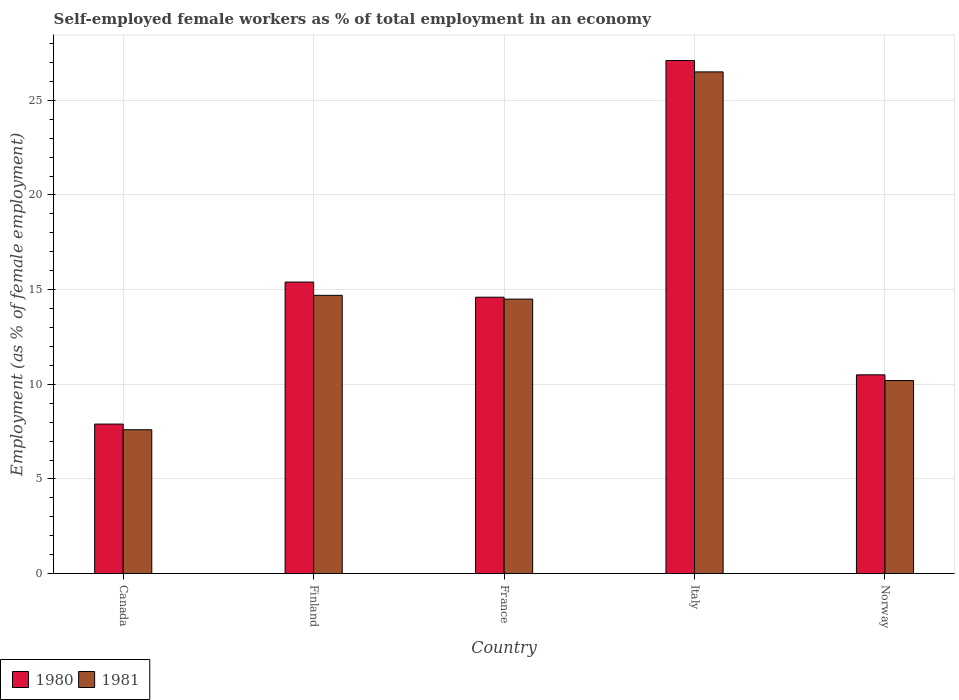Are the number of bars per tick equal to the number of legend labels?
Your answer should be compact. Yes. What is the label of the 5th group of bars from the left?
Your answer should be very brief. Norway. In how many cases, is the number of bars for a given country not equal to the number of legend labels?
Your answer should be compact. 0. What is the percentage of self-employed female workers in 1981 in France?
Your answer should be very brief. 14.5. Across all countries, what is the maximum percentage of self-employed female workers in 1980?
Give a very brief answer. 27.1. Across all countries, what is the minimum percentage of self-employed female workers in 1981?
Keep it short and to the point. 7.6. In which country was the percentage of self-employed female workers in 1981 minimum?
Keep it short and to the point. Canada. What is the total percentage of self-employed female workers in 1980 in the graph?
Offer a very short reply. 75.5. What is the difference between the percentage of self-employed female workers in 1980 in Canada and that in Italy?
Provide a short and direct response. -19.2. What is the difference between the percentage of self-employed female workers in 1981 in France and the percentage of self-employed female workers in 1980 in Italy?
Your answer should be compact. -12.6. What is the average percentage of self-employed female workers in 1980 per country?
Keep it short and to the point. 15.1. What is the difference between the percentage of self-employed female workers of/in 1981 and percentage of self-employed female workers of/in 1980 in Norway?
Offer a very short reply. -0.3. What is the ratio of the percentage of self-employed female workers in 1980 in Finland to that in France?
Your answer should be very brief. 1.05. What is the difference between the highest and the second highest percentage of self-employed female workers in 1981?
Keep it short and to the point. 11.8. What is the difference between the highest and the lowest percentage of self-employed female workers in 1981?
Make the answer very short. 18.9. In how many countries, is the percentage of self-employed female workers in 1980 greater than the average percentage of self-employed female workers in 1980 taken over all countries?
Provide a succinct answer. 2. What does the 2nd bar from the left in France represents?
Offer a very short reply. 1981. How many bars are there?
Your response must be concise. 10. How many countries are there in the graph?
Your answer should be very brief. 5. What is the difference between two consecutive major ticks on the Y-axis?
Provide a succinct answer. 5. Does the graph contain any zero values?
Your answer should be compact. No. Does the graph contain grids?
Make the answer very short. Yes. Where does the legend appear in the graph?
Ensure brevity in your answer.  Bottom left. How many legend labels are there?
Make the answer very short. 2. What is the title of the graph?
Your response must be concise. Self-employed female workers as % of total employment in an economy. What is the label or title of the X-axis?
Provide a succinct answer. Country. What is the label or title of the Y-axis?
Provide a succinct answer. Employment (as % of female employment). What is the Employment (as % of female employment) in 1980 in Canada?
Make the answer very short. 7.9. What is the Employment (as % of female employment) in 1981 in Canada?
Ensure brevity in your answer.  7.6. What is the Employment (as % of female employment) of 1980 in Finland?
Your answer should be compact. 15.4. What is the Employment (as % of female employment) of 1981 in Finland?
Give a very brief answer. 14.7. What is the Employment (as % of female employment) in 1980 in France?
Your answer should be very brief. 14.6. What is the Employment (as % of female employment) of 1980 in Italy?
Your answer should be compact. 27.1. What is the Employment (as % of female employment) of 1981 in Italy?
Provide a short and direct response. 26.5. What is the Employment (as % of female employment) of 1980 in Norway?
Your answer should be compact. 10.5. What is the Employment (as % of female employment) of 1981 in Norway?
Ensure brevity in your answer.  10.2. Across all countries, what is the maximum Employment (as % of female employment) in 1980?
Keep it short and to the point. 27.1. Across all countries, what is the minimum Employment (as % of female employment) of 1980?
Your response must be concise. 7.9. Across all countries, what is the minimum Employment (as % of female employment) of 1981?
Provide a succinct answer. 7.6. What is the total Employment (as % of female employment) in 1980 in the graph?
Your response must be concise. 75.5. What is the total Employment (as % of female employment) in 1981 in the graph?
Offer a terse response. 73.5. What is the difference between the Employment (as % of female employment) of 1980 in Canada and that in Italy?
Provide a short and direct response. -19.2. What is the difference between the Employment (as % of female employment) of 1981 in Canada and that in Italy?
Provide a succinct answer. -18.9. What is the difference between the Employment (as % of female employment) of 1980 in Canada and that in Norway?
Make the answer very short. -2.6. What is the difference between the Employment (as % of female employment) in 1980 in Finland and that in France?
Offer a very short reply. 0.8. What is the difference between the Employment (as % of female employment) of 1981 in Finland and that in France?
Offer a terse response. 0.2. What is the difference between the Employment (as % of female employment) of 1981 in Finland and that in Italy?
Keep it short and to the point. -11.8. What is the difference between the Employment (as % of female employment) in 1980 in Finland and that in Norway?
Offer a very short reply. 4.9. What is the difference between the Employment (as % of female employment) in 1981 in France and that in Italy?
Give a very brief answer. -12. What is the difference between the Employment (as % of female employment) in 1981 in France and that in Norway?
Provide a short and direct response. 4.3. What is the difference between the Employment (as % of female employment) of 1981 in Italy and that in Norway?
Keep it short and to the point. 16.3. What is the difference between the Employment (as % of female employment) of 1980 in Canada and the Employment (as % of female employment) of 1981 in France?
Offer a very short reply. -6.6. What is the difference between the Employment (as % of female employment) in 1980 in Canada and the Employment (as % of female employment) in 1981 in Italy?
Offer a very short reply. -18.6. What is the difference between the Employment (as % of female employment) of 1980 in Finland and the Employment (as % of female employment) of 1981 in France?
Your response must be concise. 0.9. What is the difference between the Employment (as % of female employment) of 1980 in Italy and the Employment (as % of female employment) of 1981 in Norway?
Offer a terse response. 16.9. What is the average Employment (as % of female employment) in 1981 per country?
Your response must be concise. 14.7. What is the difference between the Employment (as % of female employment) of 1980 and Employment (as % of female employment) of 1981 in Canada?
Give a very brief answer. 0.3. What is the difference between the Employment (as % of female employment) in 1980 and Employment (as % of female employment) in 1981 in Finland?
Your response must be concise. 0.7. What is the difference between the Employment (as % of female employment) of 1980 and Employment (as % of female employment) of 1981 in Italy?
Provide a succinct answer. 0.6. What is the ratio of the Employment (as % of female employment) in 1980 in Canada to that in Finland?
Keep it short and to the point. 0.51. What is the ratio of the Employment (as % of female employment) of 1981 in Canada to that in Finland?
Your answer should be very brief. 0.52. What is the ratio of the Employment (as % of female employment) of 1980 in Canada to that in France?
Offer a very short reply. 0.54. What is the ratio of the Employment (as % of female employment) of 1981 in Canada to that in France?
Offer a very short reply. 0.52. What is the ratio of the Employment (as % of female employment) of 1980 in Canada to that in Italy?
Offer a terse response. 0.29. What is the ratio of the Employment (as % of female employment) of 1981 in Canada to that in Italy?
Keep it short and to the point. 0.29. What is the ratio of the Employment (as % of female employment) of 1980 in Canada to that in Norway?
Keep it short and to the point. 0.75. What is the ratio of the Employment (as % of female employment) of 1981 in Canada to that in Norway?
Your answer should be compact. 0.75. What is the ratio of the Employment (as % of female employment) of 1980 in Finland to that in France?
Provide a succinct answer. 1.05. What is the ratio of the Employment (as % of female employment) of 1981 in Finland to that in France?
Provide a succinct answer. 1.01. What is the ratio of the Employment (as % of female employment) of 1980 in Finland to that in Italy?
Keep it short and to the point. 0.57. What is the ratio of the Employment (as % of female employment) in 1981 in Finland to that in Italy?
Offer a very short reply. 0.55. What is the ratio of the Employment (as % of female employment) of 1980 in Finland to that in Norway?
Keep it short and to the point. 1.47. What is the ratio of the Employment (as % of female employment) of 1981 in Finland to that in Norway?
Offer a terse response. 1.44. What is the ratio of the Employment (as % of female employment) in 1980 in France to that in Italy?
Offer a very short reply. 0.54. What is the ratio of the Employment (as % of female employment) in 1981 in France to that in Italy?
Ensure brevity in your answer.  0.55. What is the ratio of the Employment (as % of female employment) of 1980 in France to that in Norway?
Provide a short and direct response. 1.39. What is the ratio of the Employment (as % of female employment) of 1981 in France to that in Norway?
Offer a very short reply. 1.42. What is the ratio of the Employment (as % of female employment) of 1980 in Italy to that in Norway?
Your answer should be very brief. 2.58. What is the ratio of the Employment (as % of female employment) of 1981 in Italy to that in Norway?
Your answer should be compact. 2.6. What is the difference between the highest and the second highest Employment (as % of female employment) of 1981?
Offer a terse response. 11.8. What is the difference between the highest and the lowest Employment (as % of female employment) in 1980?
Your answer should be very brief. 19.2. What is the difference between the highest and the lowest Employment (as % of female employment) of 1981?
Your answer should be compact. 18.9. 